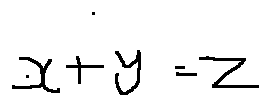Convert formula to latex. <formula><loc_0><loc_0><loc_500><loc_500>x + y = z</formula> 